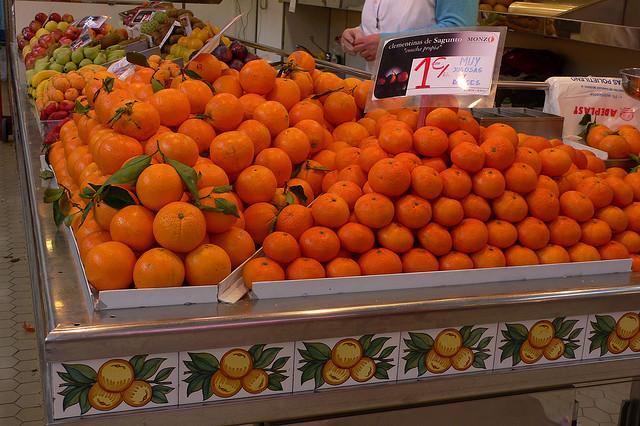How many oranges are cut?
Give a very brief answer. 0. Are the oranges been sold?
Quick response, please. No. Can these fruit be prepared for pies?
Be succinct. No. What type of vegetable is pictured?
Short answer required. Orange. Are the oranges ready to eat?
Quick response, please. Yes. What color is the fruit in the front of the display?
Concise answer only. Orange. How much for the oranges?
Concise answer only. 1. What is being sold here?
Be succinct. Oranges. How many oranges are there?
Concise answer only. Many. How much do the oranges cost?
Concise answer only. 1. How much oranges do you get for $1.25?
Answer briefly. 5. How many fruit is there?
Write a very short answer. 200. Are the oranges in a bag?
Write a very short answer. No. 